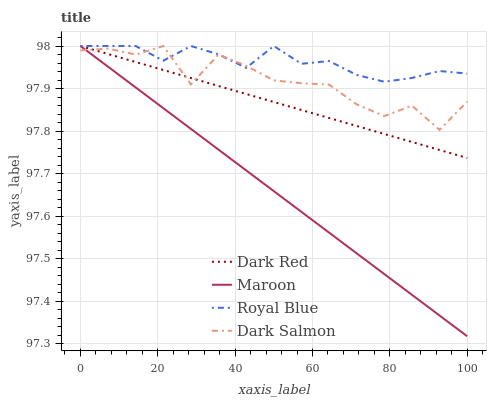Does Maroon have the minimum area under the curve?
Answer yes or no. Yes. Does Royal Blue have the maximum area under the curve?
Answer yes or no. Yes. Does Dark Salmon have the minimum area under the curve?
Answer yes or no. No. Does Dark Salmon have the maximum area under the curve?
Answer yes or no. No. Is Maroon the smoothest?
Answer yes or no. Yes. Is Dark Salmon the roughest?
Answer yes or no. Yes. Is Dark Salmon the smoothest?
Answer yes or no. No. Is Maroon the roughest?
Answer yes or no. No. Does Maroon have the lowest value?
Answer yes or no. Yes. Does Dark Salmon have the lowest value?
Answer yes or no. No. Does Royal Blue have the highest value?
Answer yes or no. Yes. Does Dark Red intersect Dark Salmon?
Answer yes or no. Yes. Is Dark Red less than Dark Salmon?
Answer yes or no. No. Is Dark Red greater than Dark Salmon?
Answer yes or no. No. 